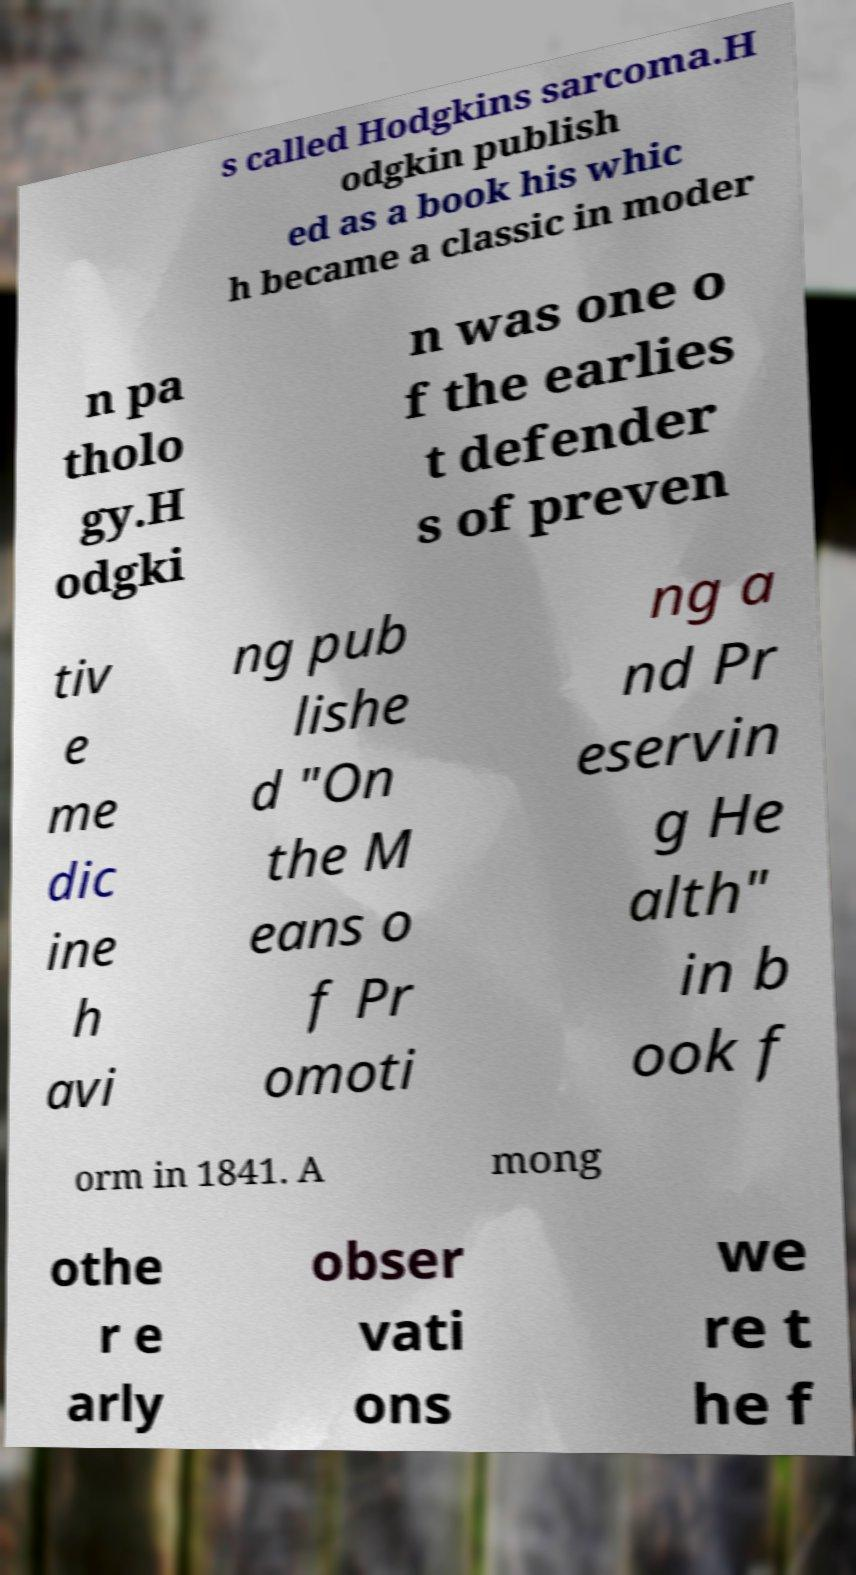Can you accurately transcribe the text from the provided image for me? s called Hodgkins sarcoma.H odgkin publish ed as a book his whic h became a classic in moder n pa tholo gy.H odgki n was one o f the earlies t defender s of preven tiv e me dic ine h avi ng pub lishe d "On the M eans o f Pr omoti ng a nd Pr eservin g He alth" in b ook f orm in 1841. A mong othe r e arly obser vati ons we re t he f 